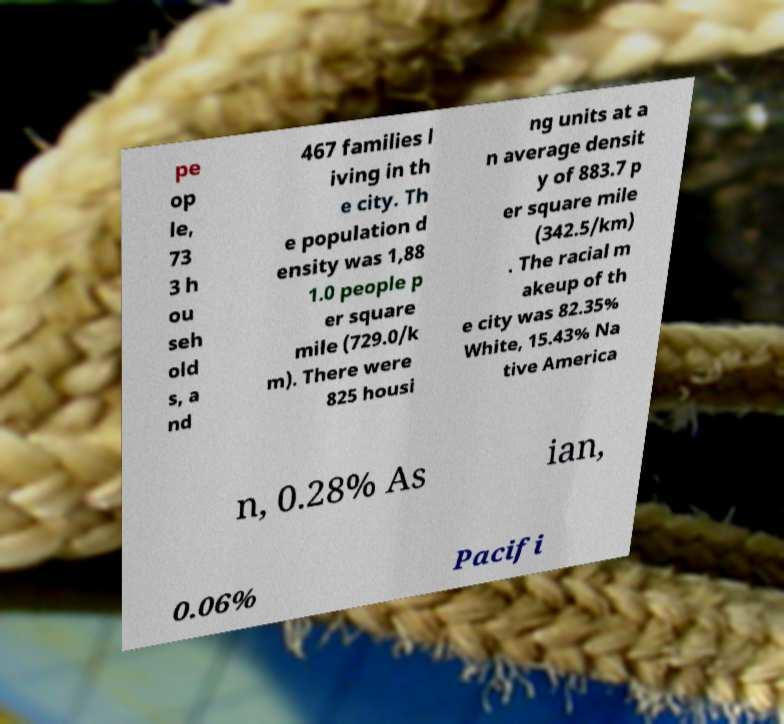Could you assist in decoding the text presented in this image and type it out clearly? pe op le, 73 3 h ou seh old s, a nd 467 families l iving in th e city. Th e population d ensity was 1,88 1.0 people p er square mile (729.0/k m). There were 825 housi ng units at a n average densit y of 883.7 p er square mile (342.5/km) . The racial m akeup of th e city was 82.35% White, 15.43% Na tive America n, 0.28% As ian, 0.06% Pacifi 